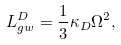Convert formula to latex. <formula><loc_0><loc_0><loc_500><loc_500>L _ { g w } ^ { D } = \frac { 1 } { 3 } \kappa _ { D } \Omega ^ { 2 } ,</formula> 